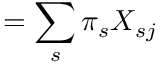<formula> <loc_0><loc_0><loc_500><loc_500>= \sum _ { s } \pi _ { s } X _ { s j }</formula> 